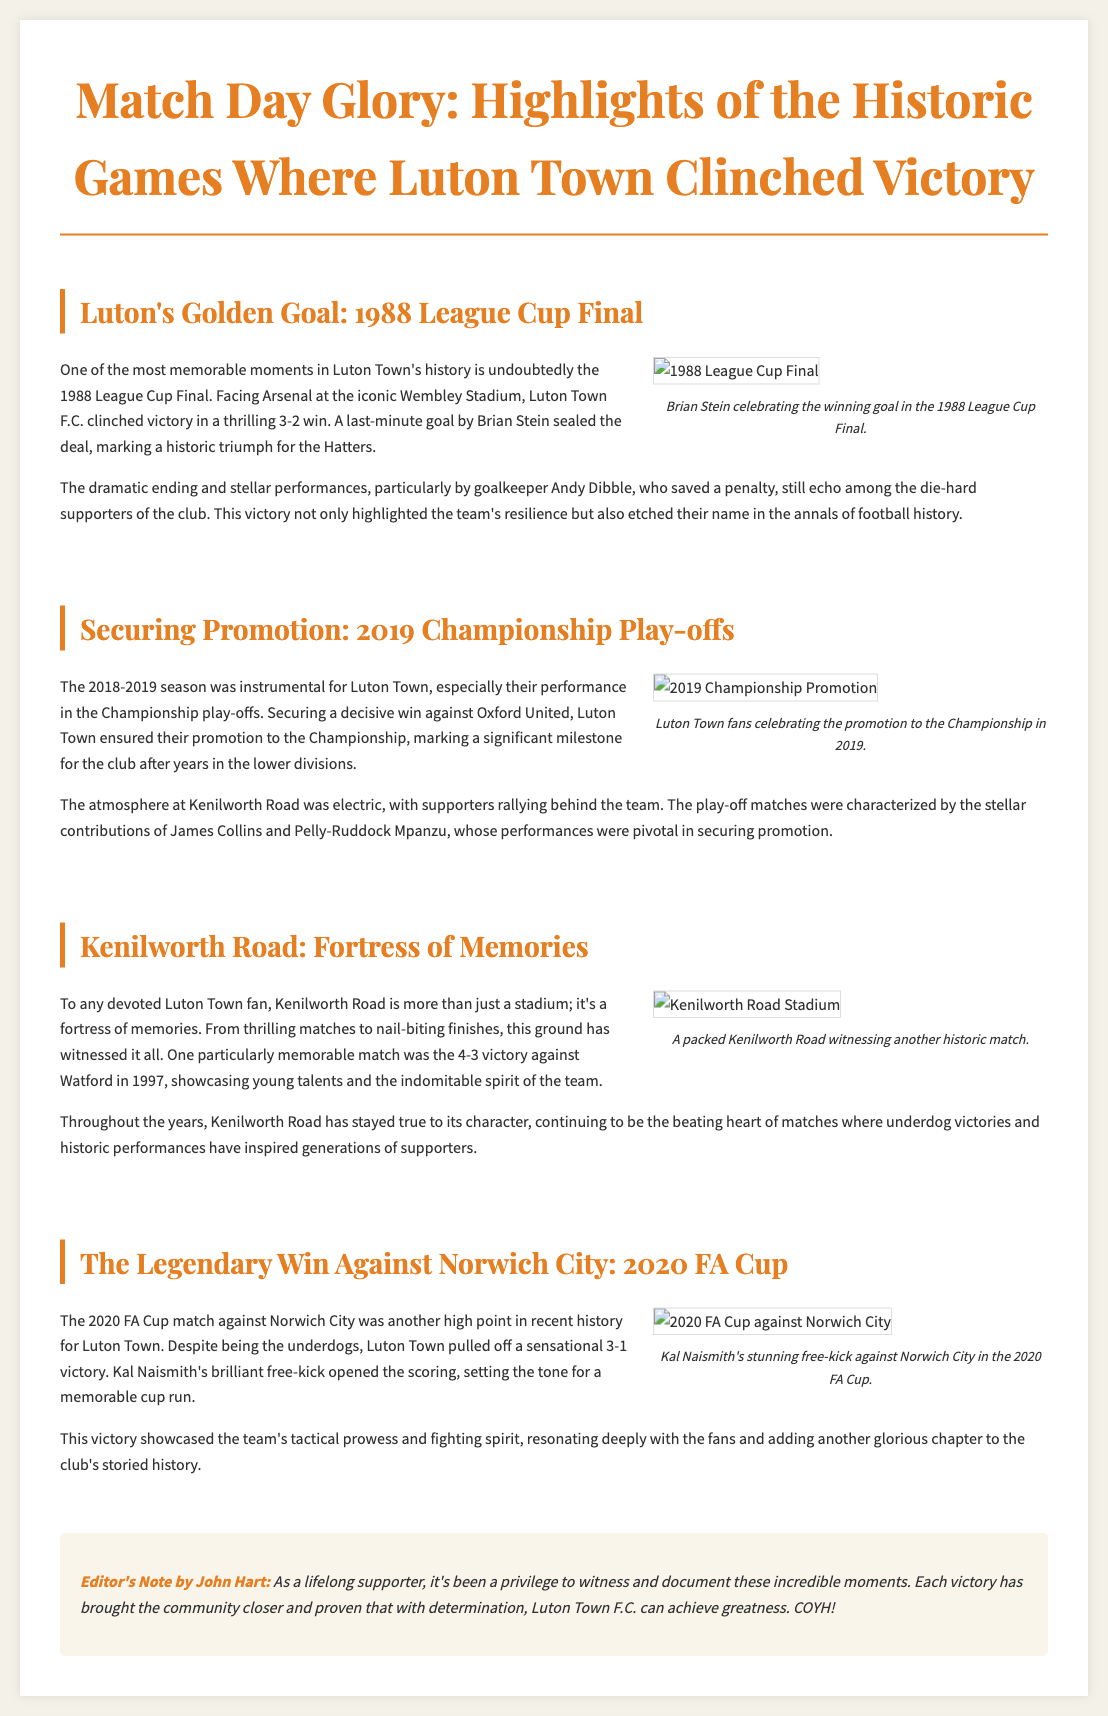What was the score of the 1988 League Cup Final? The score of the 1988 League Cup Final was mentioned as 3-2 in favor of Luton Town.
Answer: 3-2 Who scored the last-minute goal in the 1988 League Cup Final? The document states that Brian Stein scored the last-minute goal in the 1988 League Cup Final.
Answer: Brian Stein What year did Luton Town secure promotion to the Championship? The document indicates that Luton Town secured promotion in the year 2019.
Answer: 2019 Which team did Luton Town defeat in the play-offs to gain promotion? The play-off win against Oxford United is highlighted in the document as the critical match for promotion.
Answer: Oxford United What was the significant match score against Watford in 1997? The match score detailed in the article for the 1997 game against Watford was 4-3.
Answer: 4-3 What was the remarkable feat in the 2020 FA Cup match against Norwich City? The document mentions that Luton Town achieved a sensational 3-1 victory against Norwich City in the FA Cup.
Answer: 3-1 What type of kick did Kal Naismith score in the match against Norwich City? The document refers to Kal Naismith's goal as a brilliant free-kick during the match against Norwich City.
Answer: Free-kick Who wrote the editorial note? The editorial note is credited to John Hart according to the document.
Answer: John Hart What is the main theme of the newspaper article? The main theme revolves around the historic games where Luton Town clinched victory.
Answer: Historic games of victory 